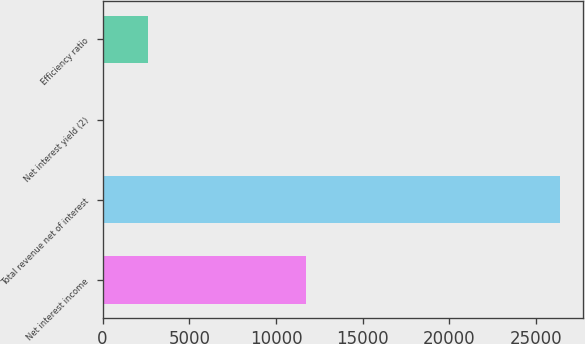Convert chart. <chart><loc_0><loc_0><loc_500><loc_500><bar_chart><fcel>Net interest income<fcel>Total revenue net of interest<fcel>Net interest yield (2)<fcel>Efficiency ratio<nl><fcel>11753<fcel>26365<fcel>2.61<fcel>2638.85<nl></chart> 